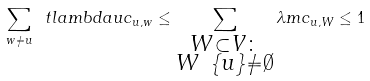<formula> <loc_0><loc_0><loc_500><loc_500>\sum _ { w \neq u } \ t l a m b d a u c _ { u , w } \leq \sum _ { \substack { W \subset V \colon \\ W \ \{ u \} \neq \emptyset } } \lambda m c _ { u , W } \leq 1</formula> 